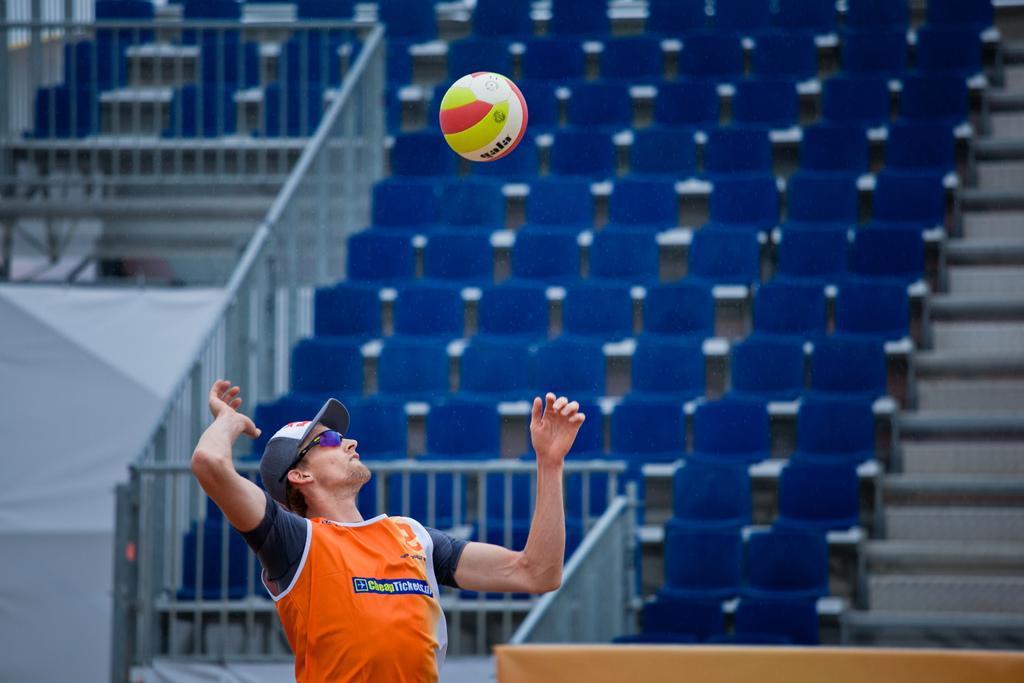Can you describe this image briefly? In this image there is a man standing, trying to hit a ball, in the background there is a railing and chairs. 